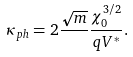<formula> <loc_0><loc_0><loc_500><loc_500>\kappa _ { p h } = 2 \frac { \sqrt { m } } { } \frac { \chi _ { 0 } ^ { 3 / 2 } } { q V ^ { \ast } } .</formula> 